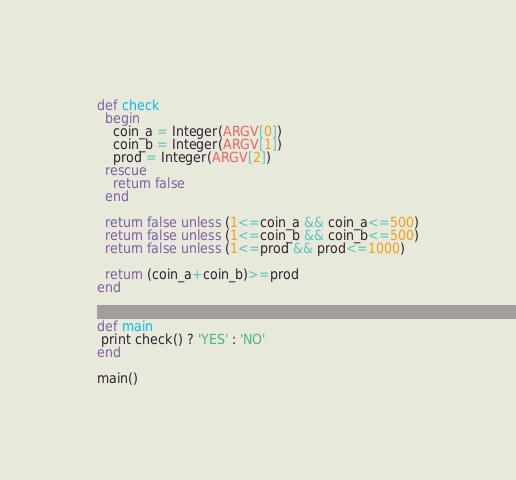Convert code to text. <code><loc_0><loc_0><loc_500><loc_500><_Ruby_>def check
  begin
    coin_a = Integer(ARGV[0])
    coin_b = Integer(ARGV[1])
    prod = Integer(ARGV[2])
  rescue
    return false
  end

  return false unless (1<=coin_a && coin_a<=500)
  return false unless (1<=coin_b && coin_b<=500)
  return false unless (1<=prod && prod<=1000)

  return (coin_a+coin_b)>=prod
end


def main
 print check() ? 'YES' : 'NO'
end

main()</code> 